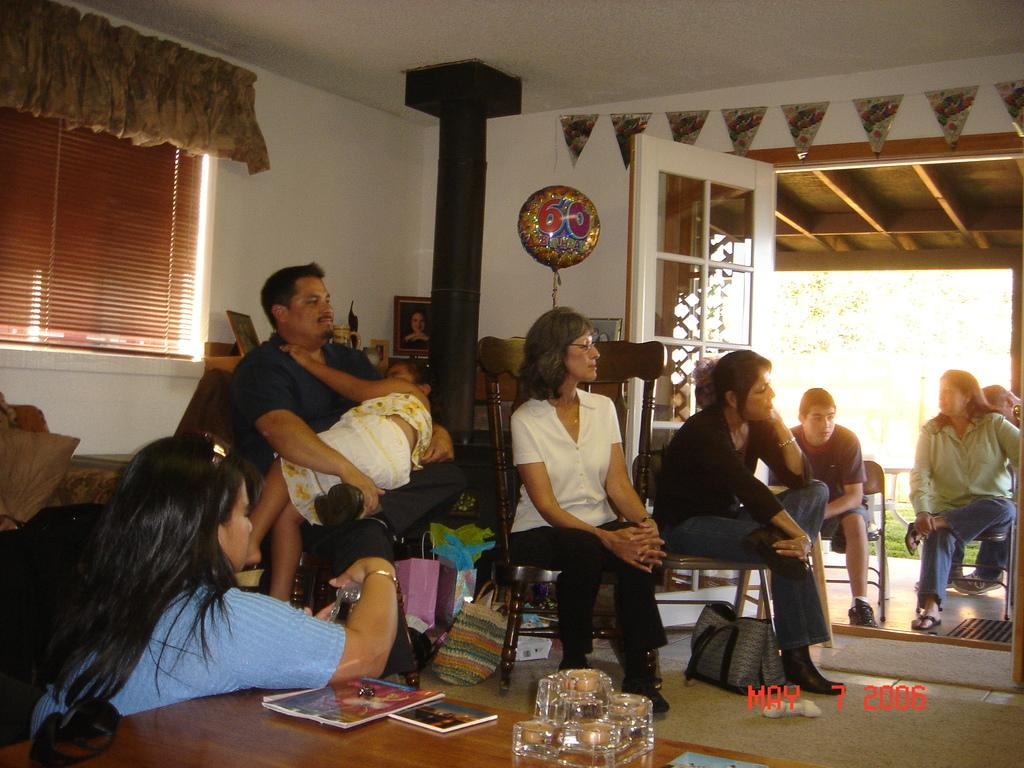What are the people in the image doing? The people in the image are sitting on chairs. What can be seen in the background of the image? There is a window with blinds, photo frames on a table, a balloon, and doors in the background of the image. What thing is being exchanged between the people in the image? There is no indication in the image that anything is being exchanged between the people. 